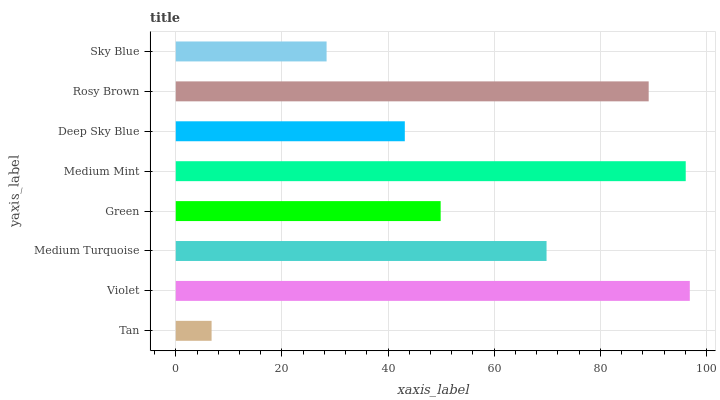Is Tan the minimum?
Answer yes or no. Yes. Is Violet the maximum?
Answer yes or no. Yes. Is Medium Turquoise the minimum?
Answer yes or no. No. Is Medium Turquoise the maximum?
Answer yes or no. No. Is Violet greater than Medium Turquoise?
Answer yes or no. Yes. Is Medium Turquoise less than Violet?
Answer yes or no. Yes. Is Medium Turquoise greater than Violet?
Answer yes or no. No. Is Violet less than Medium Turquoise?
Answer yes or no. No. Is Medium Turquoise the high median?
Answer yes or no. Yes. Is Green the low median?
Answer yes or no. Yes. Is Deep Sky Blue the high median?
Answer yes or no. No. Is Sky Blue the low median?
Answer yes or no. No. 